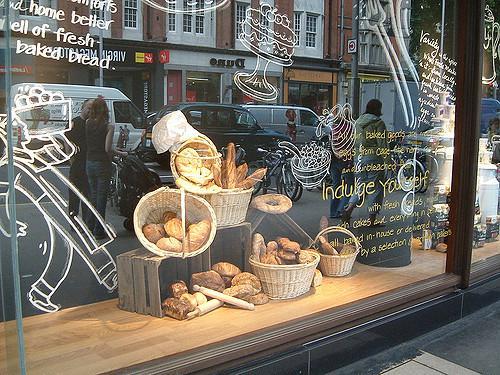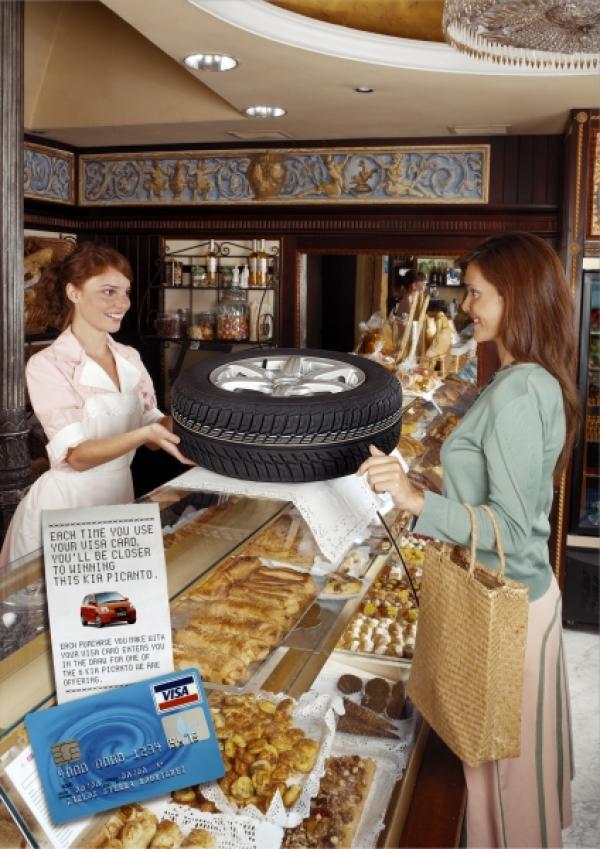The first image is the image on the left, the second image is the image on the right. Evaluate the accuracy of this statement regarding the images: "Floral arrangements are on a shelf somewhere above a glass display of bakery items.". Is it true? Answer yes or no. No. The first image is the image on the left, the second image is the image on the right. Assess this claim about the two images: "There are labels for each group of pastries in at least one of the images.". Correct or not? Answer yes or no. No. 